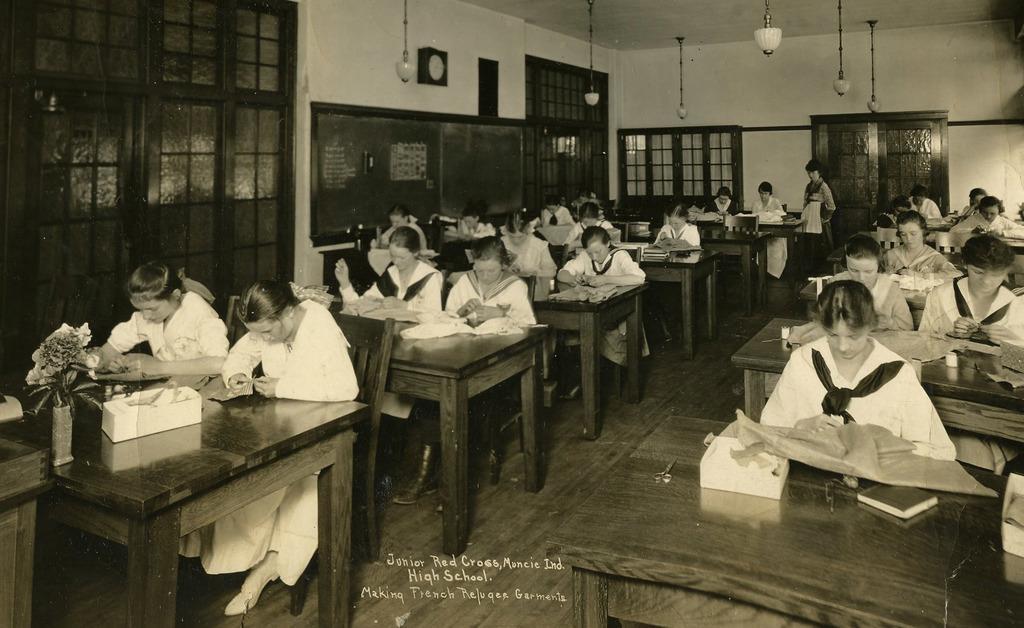Please provide a concise description of this image. In this image I can see the group of people sitting in-front of the table. On the table there is a flower vase and the books. In this room there is a board attached to the wall and the window. 